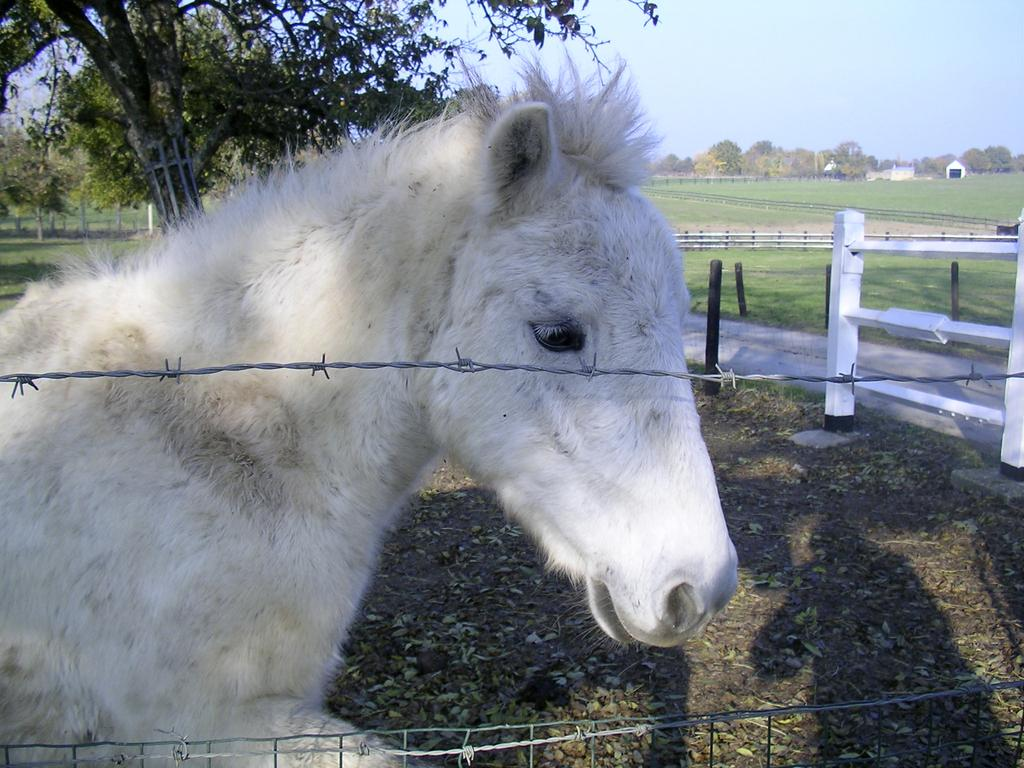What is the main subject in the foreground of the image? There is a white horse in the foreground of the image. What is located near the white horse in the foreground? There is a fencing in the foreground of the image. What can be seen in the background of the image? There are small poles, trees, a railing, grass, and the sky visible in the background of the image. What type of leather can be seen on the white horse in the image? There is no leather visible on the white horse in the image. 